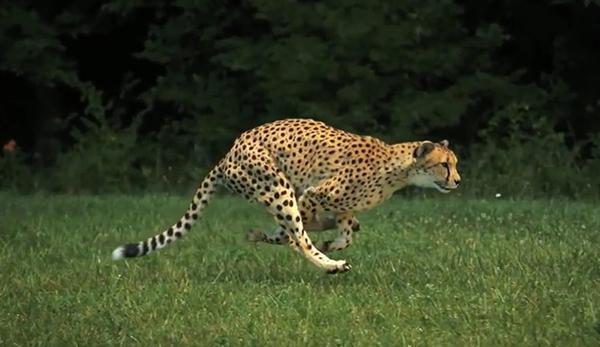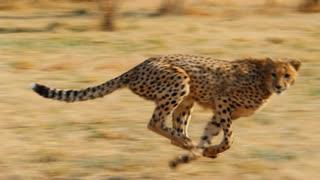The first image is the image on the left, the second image is the image on the right. Evaluate the accuracy of this statement regarding the images: "An image contains a cheetah facing towards the left.". Is it true? Answer yes or no. No. The first image is the image on the left, the second image is the image on the right. Considering the images on both sides, is "Each image shows a cheetah in a running pose, and one image shows a cheetah bounding rightward over green grass." valid? Answer yes or no. Yes. 